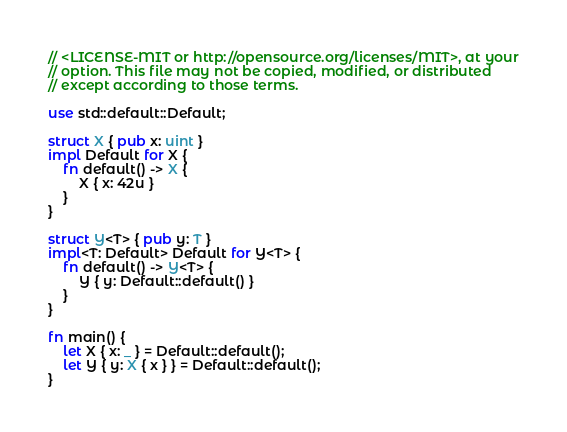Convert code to text. <code><loc_0><loc_0><loc_500><loc_500><_Rust_>// <LICENSE-MIT or http://opensource.org/licenses/MIT>, at your
// option. This file may not be copied, modified, or distributed
// except according to those terms.

use std::default::Default;

struct X { pub x: uint }
impl Default for X {
    fn default() -> X {
        X { x: 42u }
    }
}

struct Y<T> { pub y: T }
impl<T: Default> Default for Y<T> {
    fn default() -> Y<T> {
        Y { y: Default::default() }
    }
}

fn main() {
    let X { x: _ } = Default::default();
    let Y { y: X { x } } = Default::default();
}
</code> 